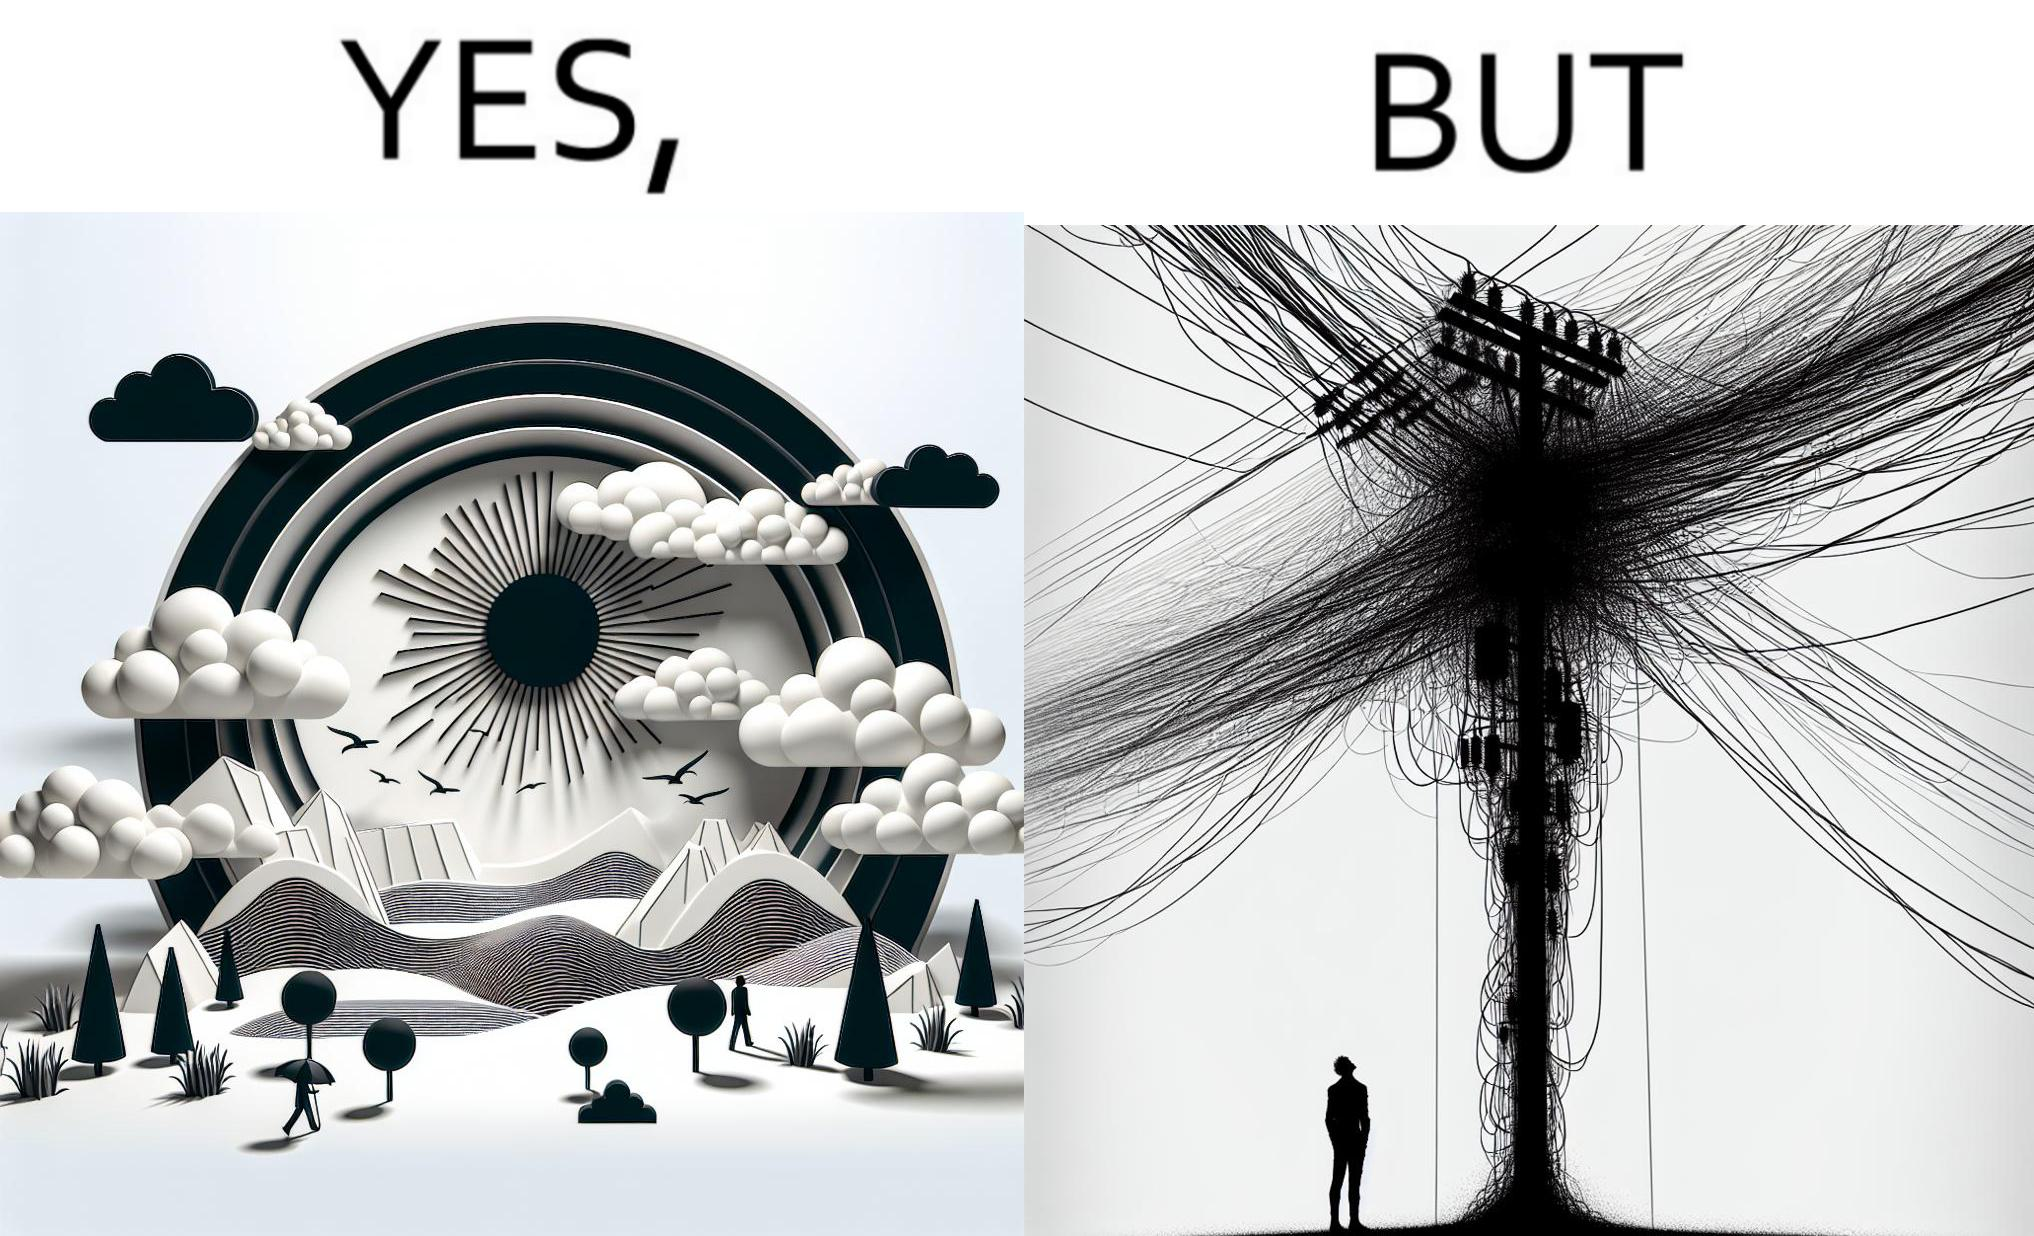What do you see in each half of this image? In the left part of the image: a clear sky with sun and clouds In the right part of the image: an electricity pole with a lot of wires over it 